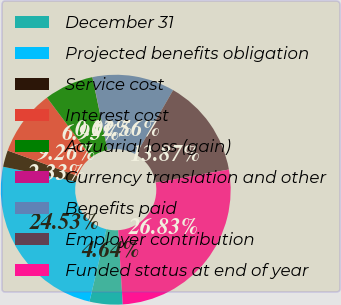Convert chart. <chart><loc_0><loc_0><loc_500><loc_500><pie_chart><fcel>December 31<fcel>Projected benefits obligation<fcel>Service cost<fcel>Interest cost<fcel>Actuarial loss (gain)<fcel>Currency translation and other<fcel>Benefits paid<fcel>Employer contribution<fcel>Funded status at end of year<nl><fcel>4.64%<fcel>24.53%<fcel>2.33%<fcel>9.26%<fcel>6.95%<fcel>0.02%<fcel>11.56%<fcel>13.87%<fcel>26.83%<nl></chart> 